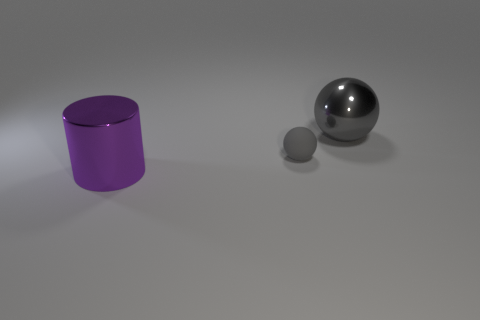Add 1 tiny rubber spheres. How many objects exist? 4 Subtract all spheres. How many objects are left? 1 Subtract 0 red cubes. How many objects are left? 3 Subtract all metal cylinders. Subtract all gray matte balls. How many objects are left? 1 Add 1 tiny gray rubber objects. How many tiny gray rubber objects are left? 2 Add 2 small gray rubber spheres. How many small gray rubber spheres exist? 3 